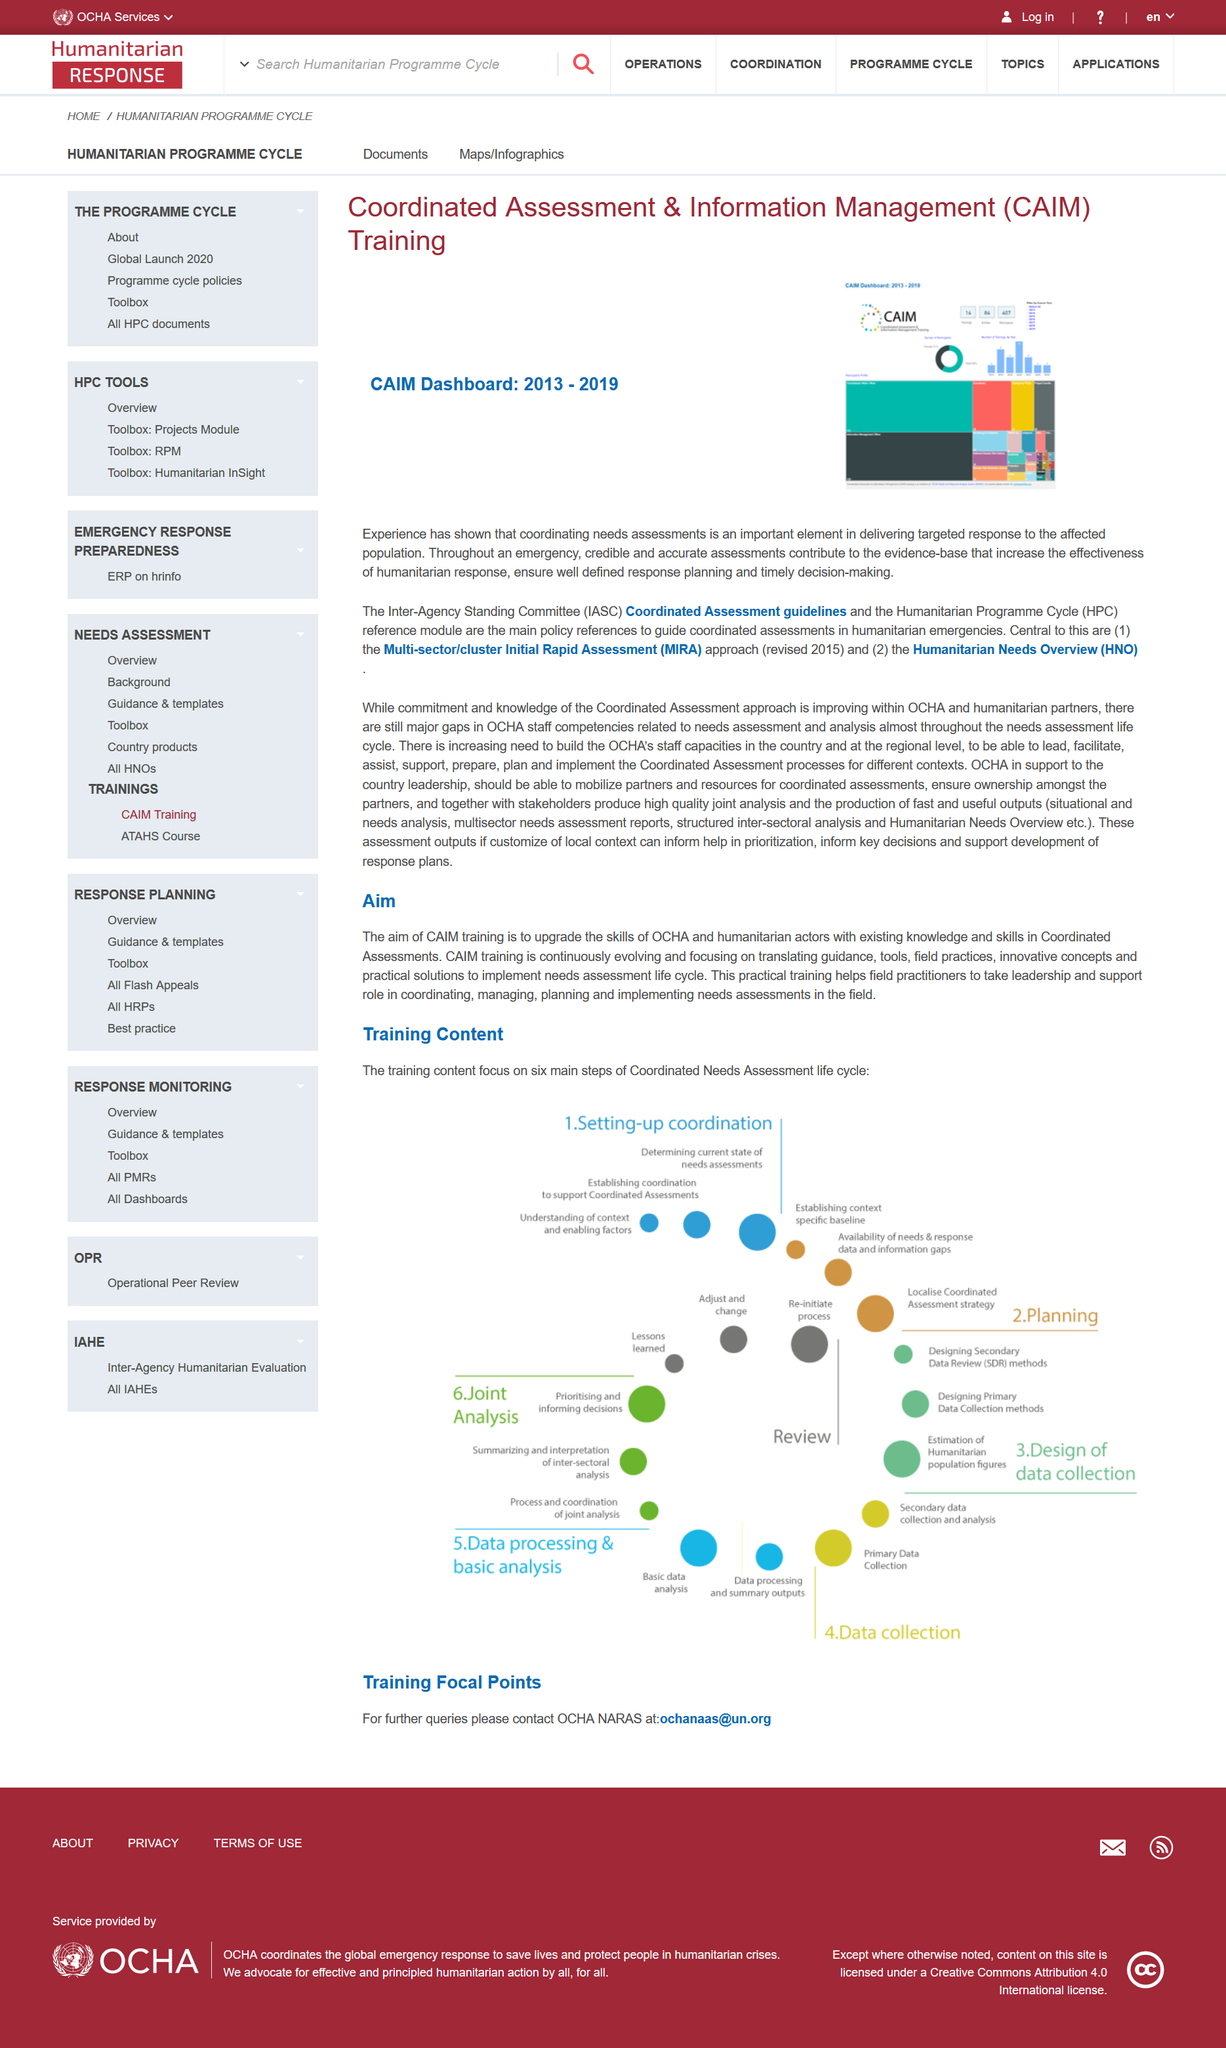List a handful of essential elements in this visual. The range of years represented in the CAIM dashboard was from 2013 to 2019. MIRA stands for a Multi-sector/cluster Initial Rapid Assessment, which provides a comprehensive evaluation of various industries and sectors in a timely and efficient manner. Coordinated Assessment & Information Management" is an acronym that stands for the phrase "What does CAIM stand for? Coordinated Assessment & Information Management..". 